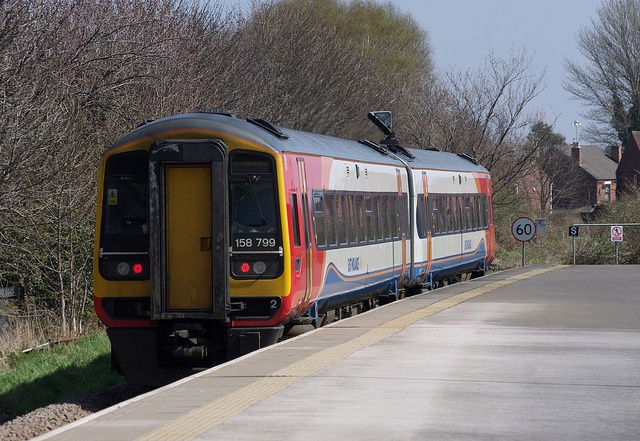Describe the objects in this image and their specific colors. I can see a train in navy, black, gray, maroon, and darkgray tones in this image. 